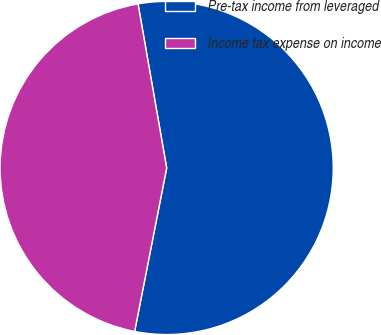<chart> <loc_0><loc_0><loc_500><loc_500><pie_chart><fcel>Pre-tax income from leveraged<fcel>Income tax expense on income<nl><fcel>55.83%<fcel>44.17%<nl></chart> 